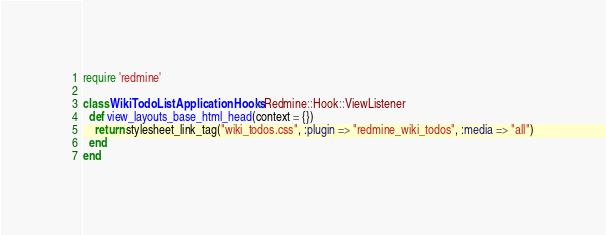Convert code to text. <code><loc_0><loc_0><loc_500><loc_500><_Ruby_>require 'redmine'

class WikiTodoListApplicationHooks < Redmine::Hook::ViewListener
  def view_layouts_base_html_head(context = {})
    return stylesheet_link_tag("wiki_todos.css", :plugin => "redmine_wiki_todos", :media => "all")
  end
end
</code> 